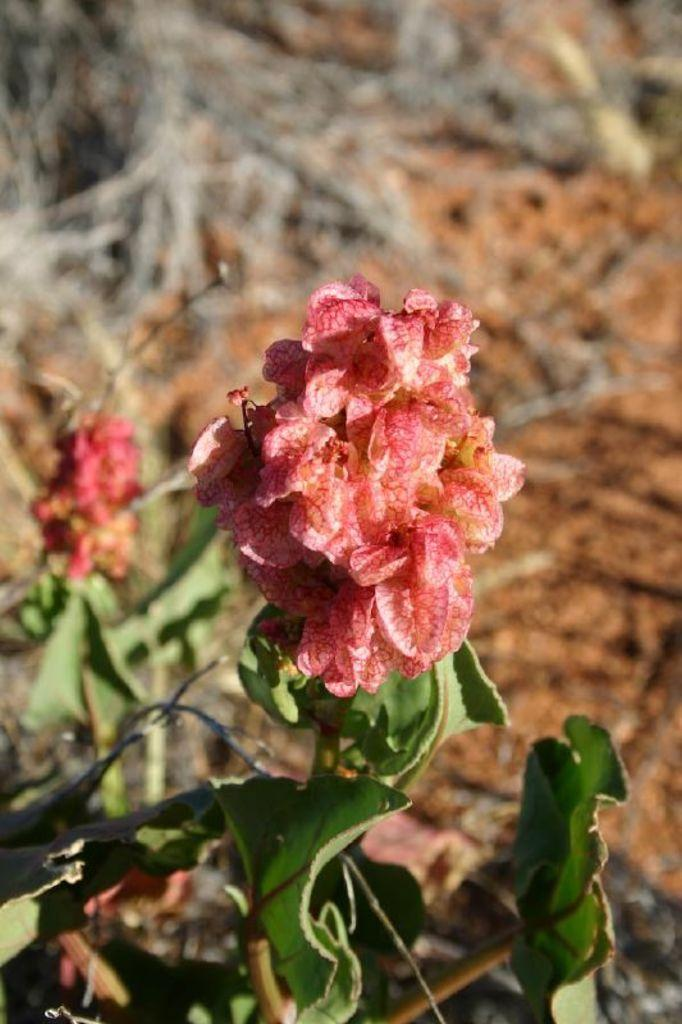What type of plants can be seen in the image? There are plants with flowers in the image. What color are the leaves of the plants? The plants have green leaves. What can be observed in the background of the image? In the background, there are dry plants and a dry ground. How many branches are visible on the plantation in the image? There is no plantation present in the image, and therefore no branches can be counted. 